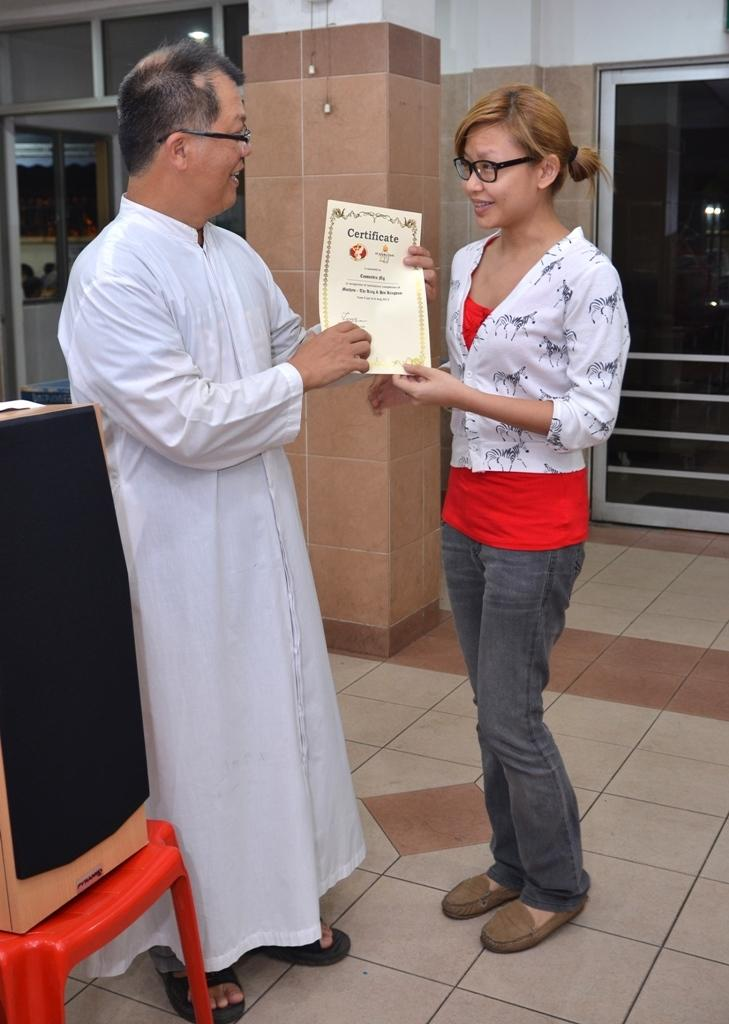How many people are in the image? There are two people in the image. What are the people doing in the image? The people are standing and holding a certificate. What can be seen on the right side of the image? There is a window on the right side of the image. What is located on the left side of the image? There is a chair on the left side of the image. What type of silk fabric is draped over the chair in the image? There is no silk fabric present in the image; the chair is empty. 